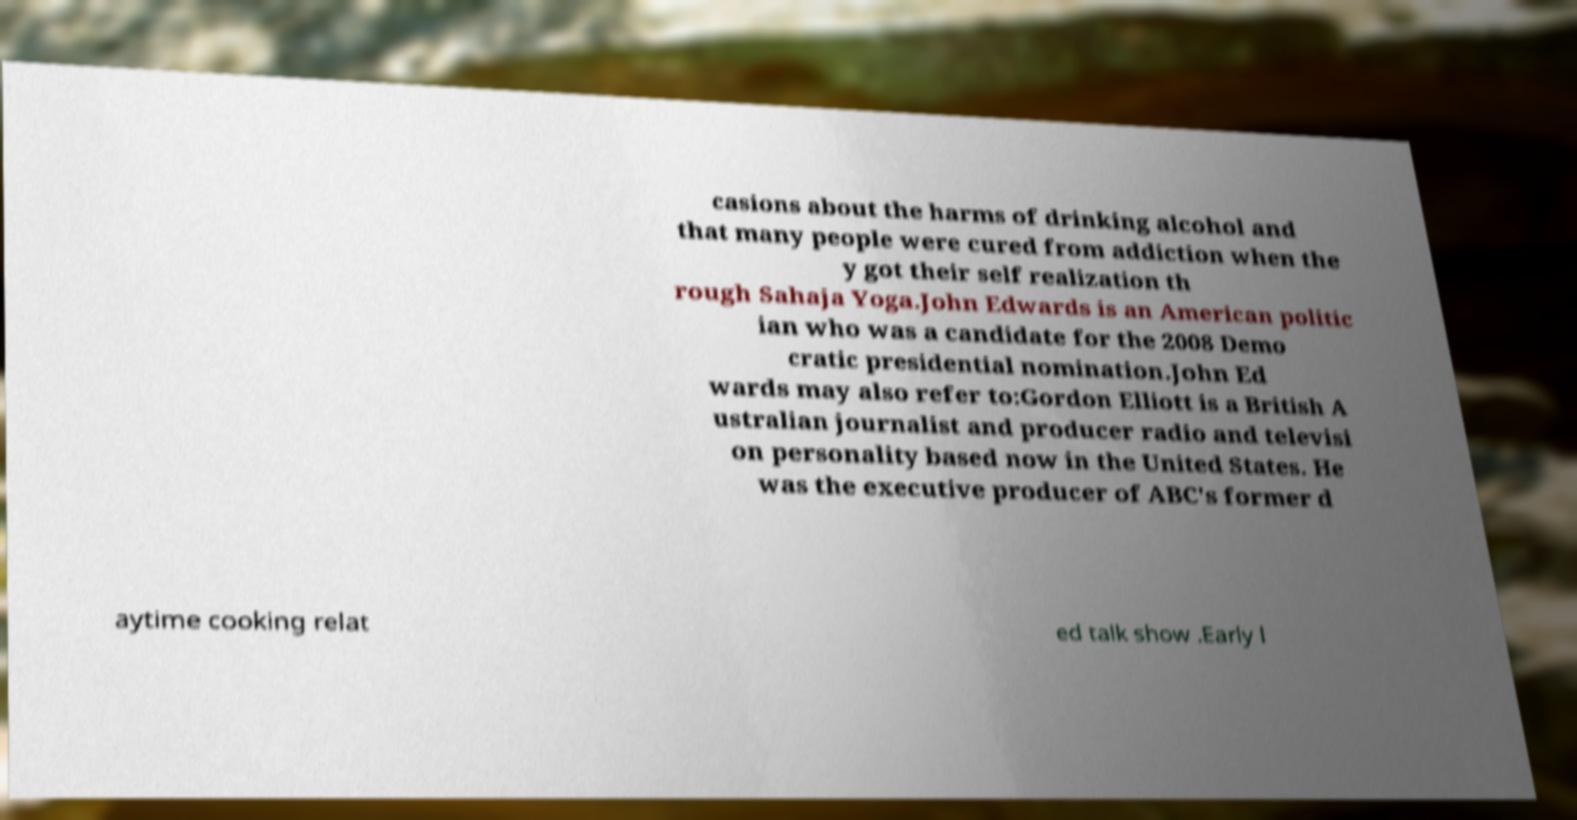I need the written content from this picture converted into text. Can you do that? casions about the harms of drinking alcohol and that many people were cured from addiction when the y got their self realization th rough Sahaja Yoga.John Edwards is an American politic ian who was a candidate for the 2008 Demo cratic presidential nomination.John Ed wards may also refer to:Gordon Elliott is a British A ustralian journalist and producer radio and televisi on personality based now in the United States. He was the executive producer of ABC's former d aytime cooking relat ed talk show .Early l 